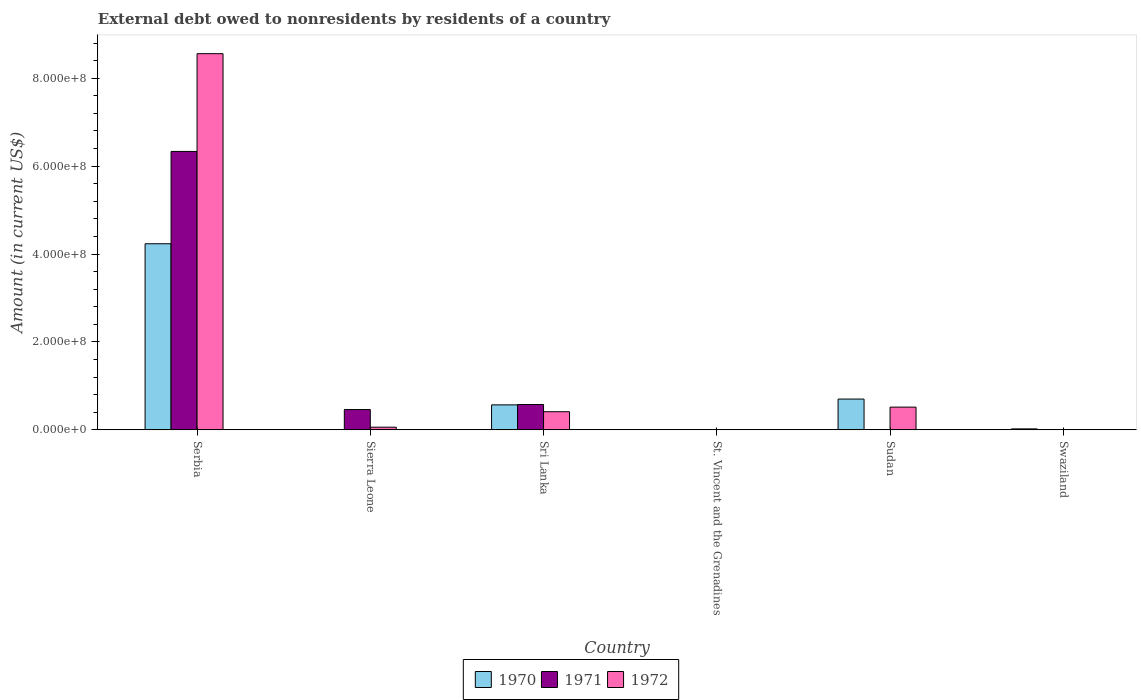How many different coloured bars are there?
Offer a terse response. 3. Are the number of bars per tick equal to the number of legend labels?
Offer a terse response. No. Are the number of bars on each tick of the X-axis equal?
Provide a succinct answer. No. How many bars are there on the 2nd tick from the left?
Ensure brevity in your answer.  2. What is the label of the 4th group of bars from the left?
Your answer should be very brief. St. Vincent and the Grenadines. Across all countries, what is the maximum external debt owed by residents in 1971?
Ensure brevity in your answer.  6.33e+08. Across all countries, what is the minimum external debt owed by residents in 1972?
Offer a very short reply. 0. In which country was the external debt owed by residents in 1970 maximum?
Your response must be concise. Serbia. What is the total external debt owed by residents in 1972 in the graph?
Provide a short and direct response. 9.55e+08. What is the difference between the external debt owed by residents in 1970 in Sri Lanka and that in Swaziland?
Your answer should be compact. 5.46e+07. What is the difference between the external debt owed by residents in 1972 in Sri Lanka and the external debt owed by residents in 1971 in St. Vincent and the Grenadines?
Your response must be concise. 4.11e+07. What is the average external debt owed by residents in 1972 per country?
Give a very brief answer. 1.59e+08. What is the difference between the external debt owed by residents of/in 1972 and external debt owed by residents of/in 1971 in Sierra Leone?
Your answer should be very brief. -4.01e+07. What is the ratio of the external debt owed by residents in 1972 in St. Vincent and the Grenadines to that in Sudan?
Ensure brevity in your answer.  0. Is the difference between the external debt owed by residents in 1972 in Sierra Leone and Sri Lanka greater than the difference between the external debt owed by residents in 1971 in Sierra Leone and Sri Lanka?
Offer a very short reply. No. What is the difference between the highest and the second highest external debt owed by residents in 1970?
Make the answer very short. 3.67e+08. What is the difference between the highest and the lowest external debt owed by residents in 1970?
Provide a succinct answer. 4.23e+08. Is it the case that in every country, the sum of the external debt owed by residents in 1972 and external debt owed by residents in 1971 is greater than the external debt owed by residents in 1970?
Offer a terse response. No. How many bars are there?
Keep it short and to the point. 14. Are all the bars in the graph horizontal?
Offer a terse response. No. How many countries are there in the graph?
Offer a terse response. 6. Does the graph contain grids?
Provide a succinct answer. No. Where does the legend appear in the graph?
Provide a short and direct response. Bottom center. What is the title of the graph?
Keep it short and to the point. External debt owed to nonresidents by residents of a country. Does "1998" appear as one of the legend labels in the graph?
Provide a short and direct response. No. What is the Amount (in current US$) of 1970 in Serbia?
Give a very brief answer. 4.23e+08. What is the Amount (in current US$) of 1971 in Serbia?
Keep it short and to the point. 6.33e+08. What is the Amount (in current US$) in 1972 in Serbia?
Ensure brevity in your answer.  8.56e+08. What is the Amount (in current US$) of 1970 in Sierra Leone?
Offer a very short reply. 0. What is the Amount (in current US$) in 1971 in Sierra Leone?
Your answer should be compact. 4.61e+07. What is the Amount (in current US$) of 1972 in Sierra Leone?
Offer a very short reply. 5.94e+06. What is the Amount (in current US$) of 1970 in Sri Lanka?
Provide a short and direct response. 5.67e+07. What is the Amount (in current US$) of 1971 in Sri Lanka?
Give a very brief answer. 5.76e+07. What is the Amount (in current US$) of 1972 in Sri Lanka?
Your response must be concise. 4.12e+07. What is the Amount (in current US$) in 1970 in St. Vincent and the Grenadines?
Your response must be concise. 3.60e+05. What is the Amount (in current US$) in 1971 in St. Vincent and the Grenadines?
Your response must be concise. 3000. What is the Amount (in current US$) of 1972 in St. Vincent and the Grenadines?
Give a very brief answer. 1.50e+04. What is the Amount (in current US$) of 1970 in Sudan?
Your answer should be compact. 7.00e+07. What is the Amount (in current US$) in 1971 in Sudan?
Your answer should be compact. 0. What is the Amount (in current US$) of 1972 in Sudan?
Keep it short and to the point. 5.16e+07. What is the Amount (in current US$) in 1970 in Swaziland?
Ensure brevity in your answer.  2.10e+06. Across all countries, what is the maximum Amount (in current US$) in 1970?
Make the answer very short. 4.23e+08. Across all countries, what is the maximum Amount (in current US$) of 1971?
Ensure brevity in your answer.  6.33e+08. Across all countries, what is the maximum Amount (in current US$) of 1972?
Provide a short and direct response. 8.56e+08. Across all countries, what is the minimum Amount (in current US$) in 1971?
Offer a very short reply. 0. What is the total Amount (in current US$) of 1970 in the graph?
Ensure brevity in your answer.  5.53e+08. What is the total Amount (in current US$) of 1971 in the graph?
Provide a short and direct response. 7.37e+08. What is the total Amount (in current US$) in 1972 in the graph?
Make the answer very short. 9.55e+08. What is the difference between the Amount (in current US$) in 1971 in Serbia and that in Sierra Leone?
Your answer should be very brief. 5.87e+08. What is the difference between the Amount (in current US$) in 1972 in Serbia and that in Sierra Leone?
Keep it short and to the point. 8.50e+08. What is the difference between the Amount (in current US$) of 1970 in Serbia and that in Sri Lanka?
Offer a terse response. 3.67e+08. What is the difference between the Amount (in current US$) in 1971 in Serbia and that in Sri Lanka?
Keep it short and to the point. 5.76e+08. What is the difference between the Amount (in current US$) of 1972 in Serbia and that in Sri Lanka?
Offer a terse response. 8.15e+08. What is the difference between the Amount (in current US$) of 1970 in Serbia and that in St. Vincent and the Grenadines?
Keep it short and to the point. 4.23e+08. What is the difference between the Amount (in current US$) in 1971 in Serbia and that in St. Vincent and the Grenadines?
Provide a succinct answer. 6.33e+08. What is the difference between the Amount (in current US$) of 1972 in Serbia and that in St. Vincent and the Grenadines?
Ensure brevity in your answer.  8.56e+08. What is the difference between the Amount (in current US$) of 1970 in Serbia and that in Sudan?
Make the answer very short. 3.53e+08. What is the difference between the Amount (in current US$) of 1972 in Serbia and that in Sudan?
Your answer should be compact. 8.04e+08. What is the difference between the Amount (in current US$) of 1970 in Serbia and that in Swaziland?
Give a very brief answer. 4.21e+08. What is the difference between the Amount (in current US$) of 1971 in Sierra Leone and that in Sri Lanka?
Ensure brevity in your answer.  -1.15e+07. What is the difference between the Amount (in current US$) in 1972 in Sierra Leone and that in Sri Lanka?
Provide a short and direct response. -3.52e+07. What is the difference between the Amount (in current US$) of 1971 in Sierra Leone and that in St. Vincent and the Grenadines?
Offer a very short reply. 4.61e+07. What is the difference between the Amount (in current US$) in 1972 in Sierra Leone and that in St. Vincent and the Grenadines?
Provide a succinct answer. 5.92e+06. What is the difference between the Amount (in current US$) in 1972 in Sierra Leone and that in Sudan?
Keep it short and to the point. -4.57e+07. What is the difference between the Amount (in current US$) in 1970 in Sri Lanka and that in St. Vincent and the Grenadines?
Offer a terse response. 5.64e+07. What is the difference between the Amount (in current US$) of 1971 in Sri Lanka and that in St. Vincent and the Grenadines?
Make the answer very short. 5.76e+07. What is the difference between the Amount (in current US$) in 1972 in Sri Lanka and that in St. Vincent and the Grenadines?
Your answer should be compact. 4.11e+07. What is the difference between the Amount (in current US$) of 1970 in Sri Lanka and that in Sudan?
Provide a succinct answer. -1.32e+07. What is the difference between the Amount (in current US$) in 1972 in Sri Lanka and that in Sudan?
Ensure brevity in your answer.  -1.05e+07. What is the difference between the Amount (in current US$) in 1970 in Sri Lanka and that in Swaziland?
Ensure brevity in your answer.  5.46e+07. What is the difference between the Amount (in current US$) in 1970 in St. Vincent and the Grenadines and that in Sudan?
Provide a succinct answer. -6.96e+07. What is the difference between the Amount (in current US$) of 1972 in St. Vincent and the Grenadines and that in Sudan?
Ensure brevity in your answer.  -5.16e+07. What is the difference between the Amount (in current US$) in 1970 in St. Vincent and the Grenadines and that in Swaziland?
Make the answer very short. -1.74e+06. What is the difference between the Amount (in current US$) in 1970 in Sudan and that in Swaziland?
Your answer should be compact. 6.79e+07. What is the difference between the Amount (in current US$) in 1970 in Serbia and the Amount (in current US$) in 1971 in Sierra Leone?
Provide a succinct answer. 3.77e+08. What is the difference between the Amount (in current US$) of 1970 in Serbia and the Amount (in current US$) of 1972 in Sierra Leone?
Offer a very short reply. 4.17e+08. What is the difference between the Amount (in current US$) of 1971 in Serbia and the Amount (in current US$) of 1972 in Sierra Leone?
Make the answer very short. 6.28e+08. What is the difference between the Amount (in current US$) of 1970 in Serbia and the Amount (in current US$) of 1971 in Sri Lanka?
Keep it short and to the point. 3.66e+08. What is the difference between the Amount (in current US$) of 1970 in Serbia and the Amount (in current US$) of 1972 in Sri Lanka?
Provide a succinct answer. 3.82e+08. What is the difference between the Amount (in current US$) of 1971 in Serbia and the Amount (in current US$) of 1972 in Sri Lanka?
Ensure brevity in your answer.  5.92e+08. What is the difference between the Amount (in current US$) in 1970 in Serbia and the Amount (in current US$) in 1971 in St. Vincent and the Grenadines?
Keep it short and to the point. 4.23e+08. What is the difference between the Amount (in current US$) in 1970 in Serbia and the Amount (in current US$) in 1972 in St. Vincent and the Grenadines?
Offer a very short reply. 4.23e+08. What is the difference between the Amount (in current US$) in 1971 in Serbia and the Amount (in current US$) in 1972 in St. Vincent and the Grenadines?
Offer a very short reply. 6.33e+08. What is the difference between the Amount (in current US$) in 1970 in Serbia and the Amount (in current US$) in 1972 in Sudan?
Provide a succinct answer. 3.72e+08. What is the difference between the Amount (in current US$) of 1971 in Serbia and the Amount (in current US$) of 1972 in Sudan?
Your answer should be compact. 5.82e+08. What is the difference between the Amount (in current US$) in 1971 in Sierra Leone and the Amount (in current US$) in 1972 in Sri Lanka?
Provide a short and direct response. 4.91e+06. What is the difference between the Amount (in current US$) of 1971 in Sierra Leone and the Amount (in current US$) of 1972 in St. Vincent and the Grenadines?
Keep it short and to the point. 4.60e+07. What is the difference between the Amount (in current US$) of 1971 in Sierra Leone and the Amount (in current US$) of 1972 in Sudan?
Your answer should be compact. -5.58e+06. What is the difference between the Amount (in current US$) of 1970 in Sri Lanka and the Amount (in current US$) of 1971 in St. Vincent and the Grenadines?
Provide a succinct answer. 5.67e+07. What is the difference between the Amount (in current US$) of 1970 in Sri Lanka and the Amount (in current US$) of 1972 in St. Vincent and the Grenadines?
Offer a terse response. 5.67e+07. What is the difference between the Amount (in current US$) in 1971 in Sri Lanka and the Amount (in current US$) in 1972 in St. Vincent and the Grenadines?
Provide a short and direct response. 5.75e+07. What is the difference between the Amount (in current US$) in 1970 in Sri Lanka and the Amount (in current US$) in 1972 in Sudan?
Provide a short and direct response. 5.09e+06. What is the difference between the Amount (in current US$) of 1971 in Sri Lanka and the Amount (in current US$) of 1972 in Sudan?
Provide a succinct answer. 5.91e+06. What is the difference between the Amount (in current US$) in 1970 in St. Vincent and the Grenadines and the Amount (in current US$) in 1972 in Sudan?
Your response must be concise. -5.13e+07. What is the difference between the Amount (in current US$) of 1971 in St. Vincent and the Grenadines and the Amount (in current US$) of 1972 in Sudan?
Your response must be concise. -5.16e+07. What is the average Amount (in current US$) in 1970 per country?
Ensure brevity in your answer.  9.21e+07. What is the average Amount (in current US$) of 1971 per country?
Give a very brief answer. 1.23e+08. What is the average Amount (in current US$) in 1972 per country?
Offer a very short reply. 1.59e+08. What is the difference between the Amount (in current US$) of 1970 and Amount (in current US$) of 1971 in Serbia?
Provide a short and direct response. -2.10e+08. What is the difference between the Amount (in current US$) in 1970 and Amount (in current US$) in 1972 in Serbia?
Your response must be concise. -4.32e+08. What is the difference between the Amount (in current US$) of 1971 and Amount (in current US$) of 1972 in Serbia?
Keep it short and to the point. -2.22e+08. What is the difference between the Amount (in current US$) in 1971 and Amount (in current US$) in 1972 in Sierra Leone?
Give a very brief answer. 4.01e+07. What is the difference between the Amount (in current US$) of 1970 and Amount (in current US$) of 1971 in Sri Lanka?
Make the answer very short. -8.21e+05. What is the difference between the Amount (in current US$) in 1970 and Amount (in current US$) in 1972 in Sri Lanka?
Offer a terse response. 1.56e+07. What is the difference between the Amount (in current US$) of 1971 and Amount (in current US$) of 1972 in Sri Lanka?
Make the answer very short. 1.64e+07. What is the difference between the Amount (in current US$) in 1970 and Amount (in current US$) in 1971 in St. Vincent and the Grenadines?
Offer a very short reply. 3.57e+05. What is the difference between the Amount (in current US$) of 1970 and Amount (in current US$) of 1972 in St. Vincent and the Grenadines?
Offer a terse response. 3.45e+05. What is the difference between the Amount (in current US$) of 1971 and Amount (in current US$) of 1972 in St. Vincent and the Grenadines?
Ensure brevity in your answer.  -1.20e+04. What is the difference between the Amount (in current US$) of 1970 and Amount (in current US$) of 1972 in Sudan?
Make the answer very short. 1.83e+07. What is the ratio of the Amount (in current US$) of 1971 in Serbia to that in Sierra Leone?
Ensure brevity in your answer.  13.75. What is the ratio of the Amount (in current US$) in 1972 in Serbia to that in Sierra Leone?
Give a very brief answer. 144.15. What is the ratio of the Amount (in current US$) in 1970 in Serbia to that in Sri Lanka?
Your answer should be very brief. 7.46. What is the ratio of the Amount (in current US$) in 1971 in Serbia to that in Sri Lanka?
Your answer should be compact. 11.01. What is the ratio of the Amount (in current US$) of 1972 in Serbia to that in Sri Lanka?
Your response must be concise. 20.8. What is the ratio of the Amount (in current US$) in 1970 in Serbia to that in St. Vincent and the Grenadines?
Provide a succinct answer. 1175.96. What is the ratio of the Amount (in current US$) of 1971 in Serbia to that in St. Vincent and the Grenadines?
Make the answer very short. 2.11e+05. What is the ratio of the Amount (in current US$) in 1972 in Serbia to that in St. Vincent and the Grenadines?
Provide a short and direct response. 5.71e+04. What is the ratio of the Amount (in current US$) of 1970 in Serbia to that in Sudan?
Provide a short and direct response. 6.05. What is the ratio of the Amount (in current US$) in 1972 in Serbia to that in Sudan?
Provide a short and direct response. 16.57. What is the ratio of the Amount (in current US$) in 1970 in Serbia to that in Swaziland?
Your answer should be very brief. 201.12. What is the ratio of the Amount (in current US$) of 1971 in Sierra Leone to that in Sri Lanka?
Offer a terse response. 0.8. What is the ratio of the Amount (in current US$) in 1972 in Sierra Leone to that in Sri Lanka?
Provide a succinct answer. 0.14. What is the ratio of the Amount (in current US$) of 1971 in Sierra Leone to that in St. Vincent and the Grenadines?
Provide a succinct answer. 1.54e+04. What is the ratio of the Amount (in current US$) in 1972 in Sierra Leone to that in St. Vincent and the Grenadines?
Provide a short and direct response. 395.8. What is the ratio of the Amount (in current US$) of 1972 in Sierra Leone to that in Sudan?
Ensure brevity in your answer.  0.12. What is the ratio of the Amount (in current US$) in 1970 in Sri Lanka to that in St. Vincent and the Grenadines?
Offer a very short reply. 157.59. What is the ratio of the Amount (in current US$) of 1971 in Sri Lanka to that in St. Vincent and the Grenadines?
Your answer should be very brief. 1.92e+04. What is the ratio of the Amount (in current US$) of 1972 in Sri Lanka to that in St. Vincent and the Grenadines?
Ensure brevity in your answer.  2743.4. What is the ratio of the Amount (in current US$) of 1970 in Sri Lanka to that in Sudan?
Provide a succinct answer. 0.81. What is the ratio of the Amount (in current US$) in 1972 in Sri Lanka to that in Sudan?
Your answer should be very brief. 0.8. What is the ratio of the Amount (in current US$) in 1970 in Sri Lanka to that in Swaziland?
Keep it short and to the point. 26.95. What is the ratio of the Amount (in current US$) in 1970 in St. Vincent and the Grenadines to that in Sudan?
Provide a succinct answer. 0.01. What is the ratio of the Amount (in current US$) in 1972 in St. Vincent and the Grenadines to that in Sudan?
Offer a very short reply. 0. What is the ratio of the Amount (in current US$) in 1970 in St. Vincent and the Grenadines to that in Swaziland?
Make the answer very short. 0.17. What is the ratio of the Amount (in current US$) in 1970 in Sudan to that in Swaziland?
Ensure brevity in your answer.  33.24. What is the difference between the highest and the second highest Amount (in current US$) in 1970?
Offer a very short reply. 3.53e+08. What is the difference between the highest and the second highest Amount (in current US$) of 1971?
Your answer should be very brief. 5.76e+08. What is the difference between the highest and the second highest Amount (in current US$) of 1972?
Your response must be concise. 8.04e+08. What is the difference between the highest and the lowest Amount (in current US$) in 1970?
Your answer should be very brief. 4.23e+08. What is the difference between the highest and the lowest Amount (in current US$) in 1971?
Give a very brief answer. 6.33e+08. What is the difference between the highest and the lowest Amount (in current US$) in 1972?
Offer a terse response. 8.56e+08. 